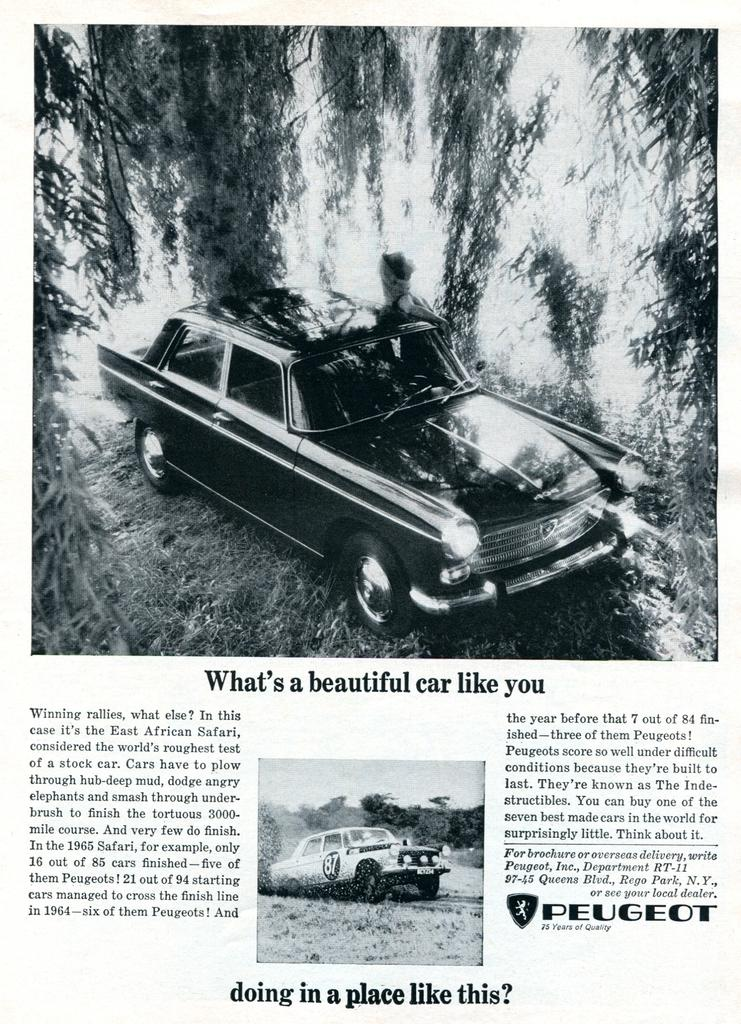What is the main object in the image? There is a poster in the image. What can be found at the bottom of the poster? There is text at the bottom of the poster. How many images are on the poster? The poster contains two black and white images. What is depicted in the images on the poster? In the images, there are cars and trees. What type of toothbrush is shown in the image? There is no toothbrush present in the image; it features a poster with two black and white images of cars and trees. 